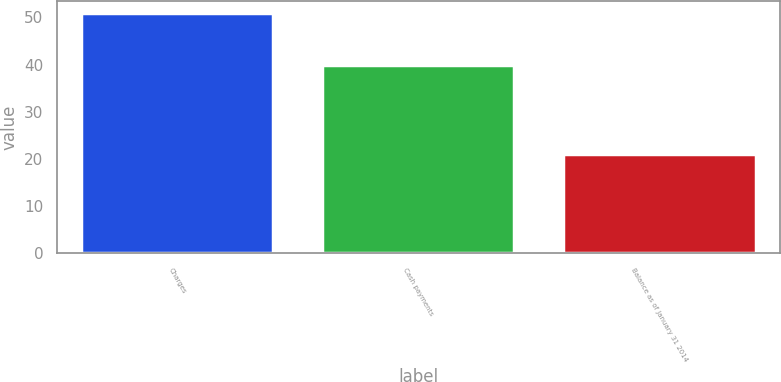Convert chart to OTSL. <chart><loc_0><loc_0><loc_500><loc_500><bar_chart><fcel>Charges<fcel>Cash payments<fcel>Balance as of January 31 2014<nl><fcel>51<fcel>40<fcel>21<nl></chart> 